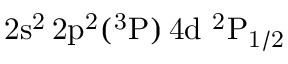Convert formula to latex. <formula><loc_0><loc_0><loc_500><loc_500>2 s ^ { 2 } \, 2 p ^ { 2 } ( ^ { 3 } P ) \, 4 d ^ { 2 } P _ { 1 / 2 }</formula> 